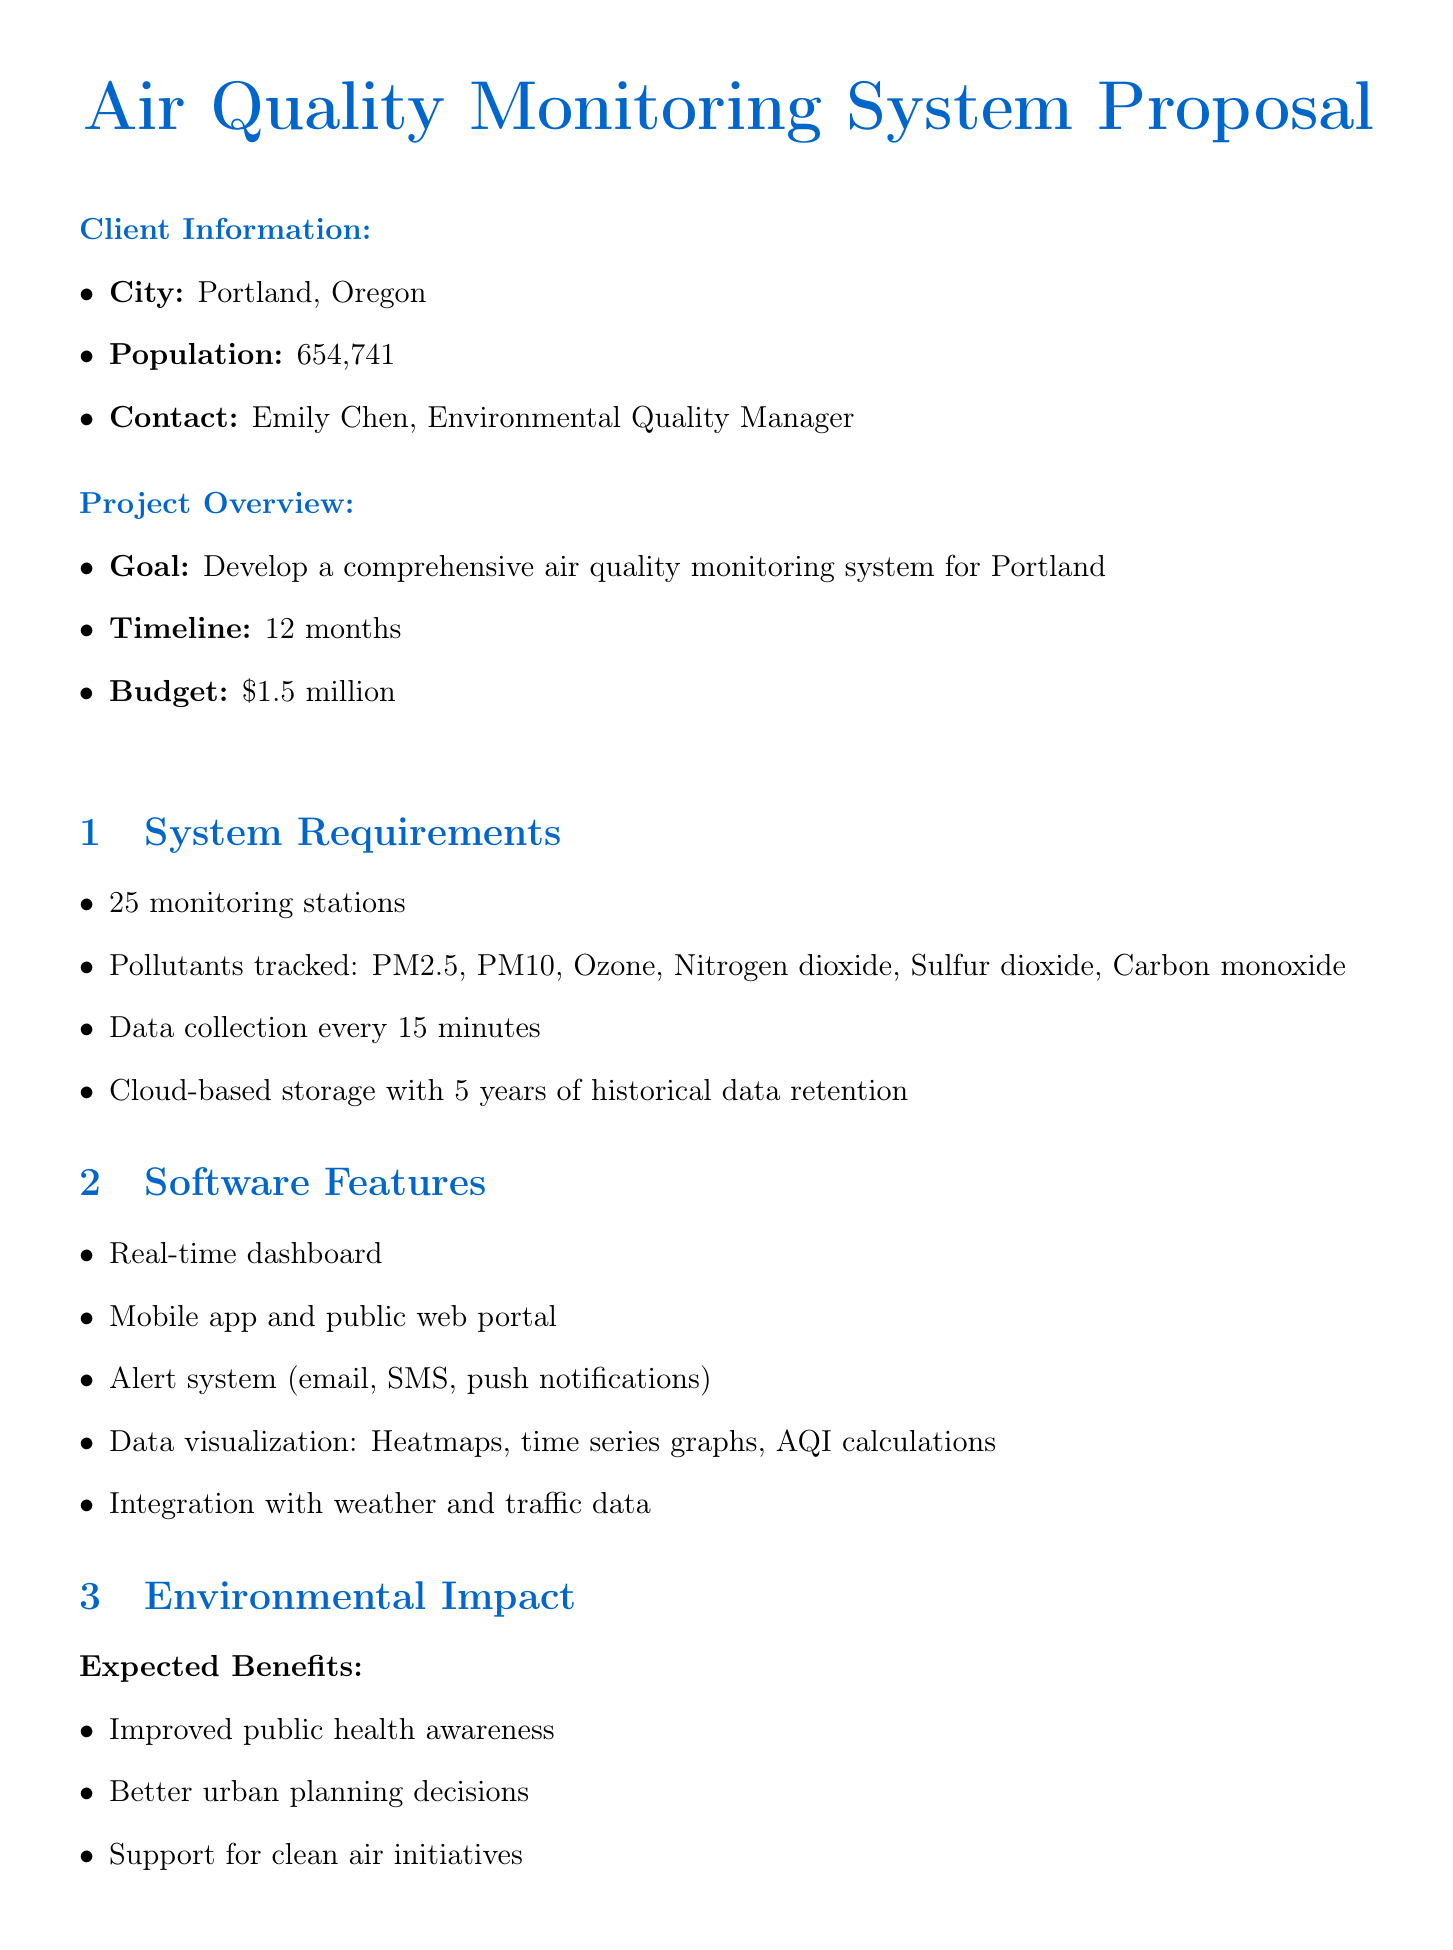What is the city for the air quality monitoring system proposal? The proposal specifies that the air quality monitoring system is for Portland, Oregon.
Answer: Portland, Oregon Who is the contact person for the project? The document states that Emily Chen is the contact person for the project.
Answer: Emily Chen What is the total budget for the project? The proposal outlines the budget as $1.5 million for developing the air quality monitoring system.
Answer: $1.5 million How many monitoring stations are proposed? According to the document, a total of 25 monitoring stations are proposed for the project.
Answer: 25 What is the data collection frequency for the monitoring system? The proposal indicates that data will be collected every 15 minutes for the air quality monitoring system.
Answer: Every 15 minutes Which pollutants are to be tracked in the system? The document lists the pollutants to track as PM2.5, PM10, Ozone, Nitrogen dioxide, Sulfur dioxide, and Carbon monoxide.
Answer: PM2.5, PM10, Ozone, Nitrogen dioxide, Sulfur dioxide, Carbon monoxide What is one expected benefit of the project? The document mentions that improved public health awareness is one of the expected benefits of the air quality monitoring system.
Answer: Improved public health awareness What programming languages are mentioned for the system development? The proposal specifies that Python, JavaScript, and R are the programming languages to be used.
Answer: Python, JavaScript, R What is the success metric for mobile app downloads? The document states that the success metric is to achieve 50,000 mobile app downloads within the first year.
Answer: 50,000 mobile app downloads 